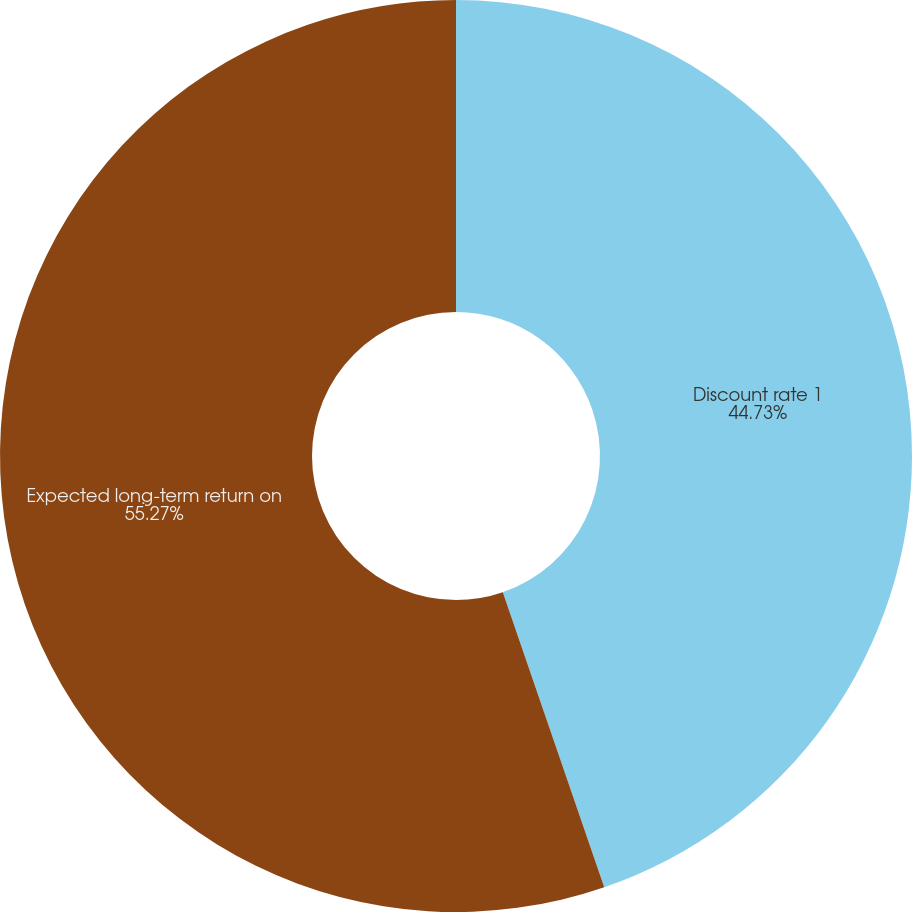Convert chart. <chart><loc_0><loc_0><loc_500><loc_500><pie_chart><fcel>Discount rate 1<fcel>Expected long-term return on<nl><fcel>44.73%<fcel>55.27%<nl></chart> 